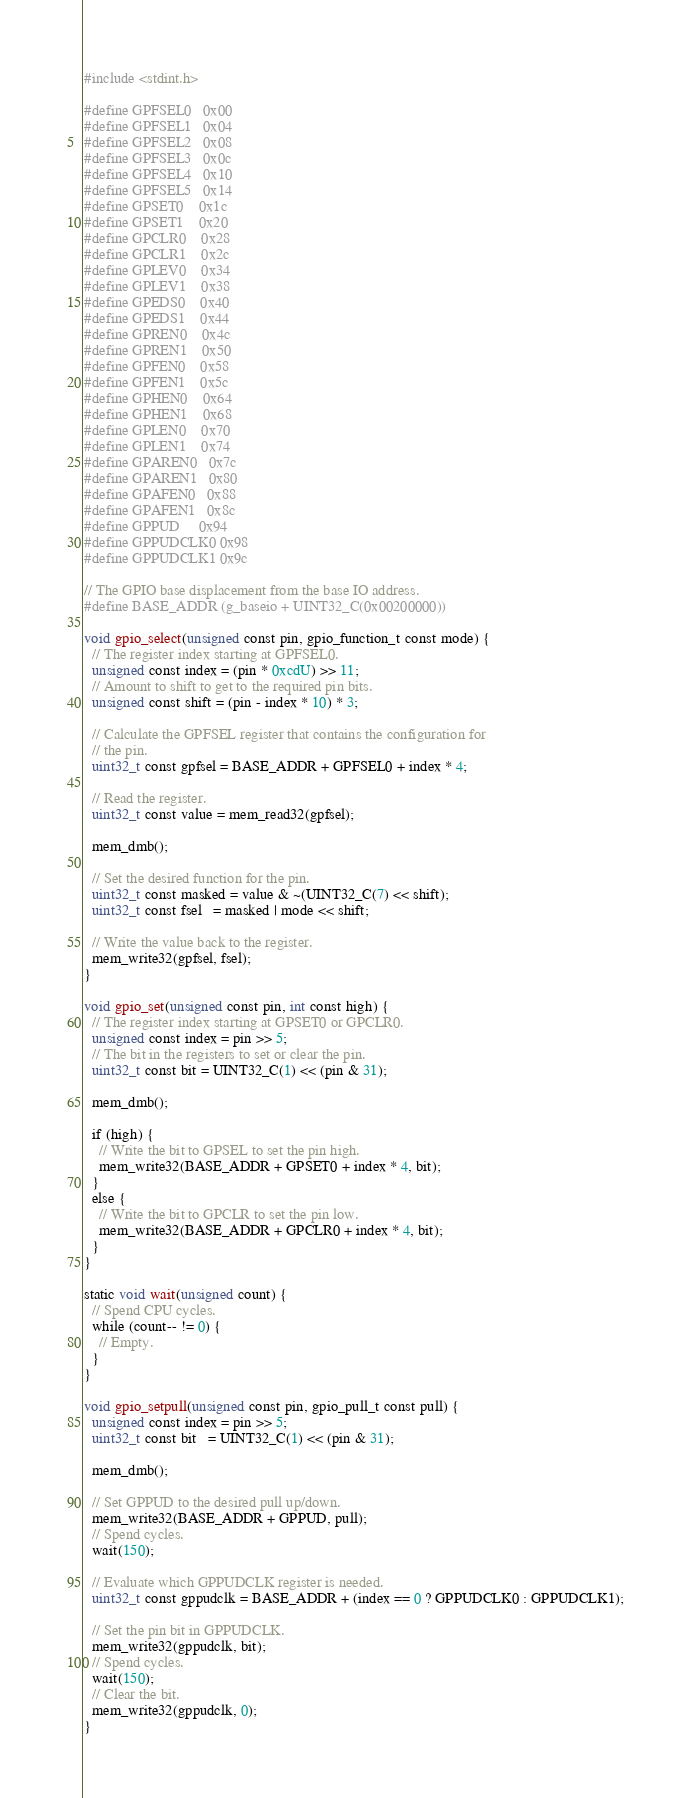<code> <loc_0><loc_0><loc_500><loc_500><_C_>
#include <stdint.h>

#define GPFSEL0   0x00
#define GPFSEL1   0x04
#define GPFSEL2   0x08
#define GPFSEL3   0x0c
#define GPFSEL4   0x10
#define GPFSEL5   0x14
#define GPSET0    0x1c
#define GPSET1    0x20
#define GPCLR0    0x28
#define GPCLR1    0x2c
#define GPLEV0    0x34
#define GPLEV1    0x38
#define GPEDS0    0x40
#define GPEDS1    0x44
#define GPREN0    0x4c
#define GPREN1    0x50
#define GPFEN0    0x58
#define GPFEN1    0x5c
#define GPHEN0    0x64
#define GPHEN1    0x68
#define GPLEN0    0x70
#define GPLEN1    0x74
#define GPAREN0   0x7c
#define GPAREN1   0x80
#define GPAFEN0   0x88
#define GPAFEN1   0x8c
#define GPPUD     0x94
#define GPPUDCLK0 0x98
#define GPPUDCLK1 0x9c

// The GPIO base displacement from the base IO address.
#define BASE_ADDR (g_baseio + UINT32_C(0x00200000))

void gpio_select(unsigned const pin, gpio_function_t const mode) {
  // The register index starting at GPFSEL0.
  unsigned const index = (pin * 0xcdU) >> 11;
  // Amount to shift to get to the required pin bits.
  unsigned const shift = (pin - index * 10) * 3;

  // Calculate the GPFSEL register that contains the configuration for
  // the pin.
  uint32_t const gpfsel = BASE_ADDR + GPFSEL0 + index * 4;

  // Read the register.
  uint32_t const value = mem_read32(gpfsel);

  mem_dmb();

  // Set the desired function for the pin.
  uint32_t const masked = value & ~(UINT32_C(7) << shift);
  uint32_t const fsel   = masked | mode << shift;

  // Write the value back to the register.
  mem_write32(gpfsel, fsel);
}

void gpio_set(unsigned const pin, int const high) {
  // The register index starting at GPSET0 or GPCLR0.
  unsigned const index = pin >> 5;
  // The bit in the registers to set or clear the pin.
  uint32_t const bit = UINT32_C(1) << (pin & 31);

  mem_dmb();

  if (high) {
    // Write the bit to GPSEL to set the pin high.
    mem_write32(BASE_ADDR + GPSET0 + index * 4, bit);
  }
  else {
    // Write the bit to GPCLR to set the pin low.
    mem_write32(BASE_ADDR + GPCLR0 + index * 4, bit);
  }
}

static void wait(unsigned count) {
  // Spend CPU cycles.
  while (count-- != 0) {
    // Empty.
  }
}

void gpio_setpull(unsigned const pin, gpio_pull_t const pull) {
  unsigned const index = pin >> 5;
  uint32_t const bit   = UINT32_C(1) << (pin & 31);

  mem_dmb();

  // Set GPPUD to the desired pull up/down.
  mem_write32(BASE_ADDR + GPPUD, pull);
  // Spend cycles.
  wait(150);

  // Evaluate which GPPUDCLK register is needed.
  uint32_t const gppudclk = BASE_ADDR + (index == 0 ? GPPUDCLK0 : GPPUDCLK1);

  // Set the pin bit in GPPUDCLK.
  mem_write32(gppudclk, bit);
  // Spend cycles.
  wait(150);
  // Clear the bit.
  mem_write32(gppudclk, 0);
}
</code> 